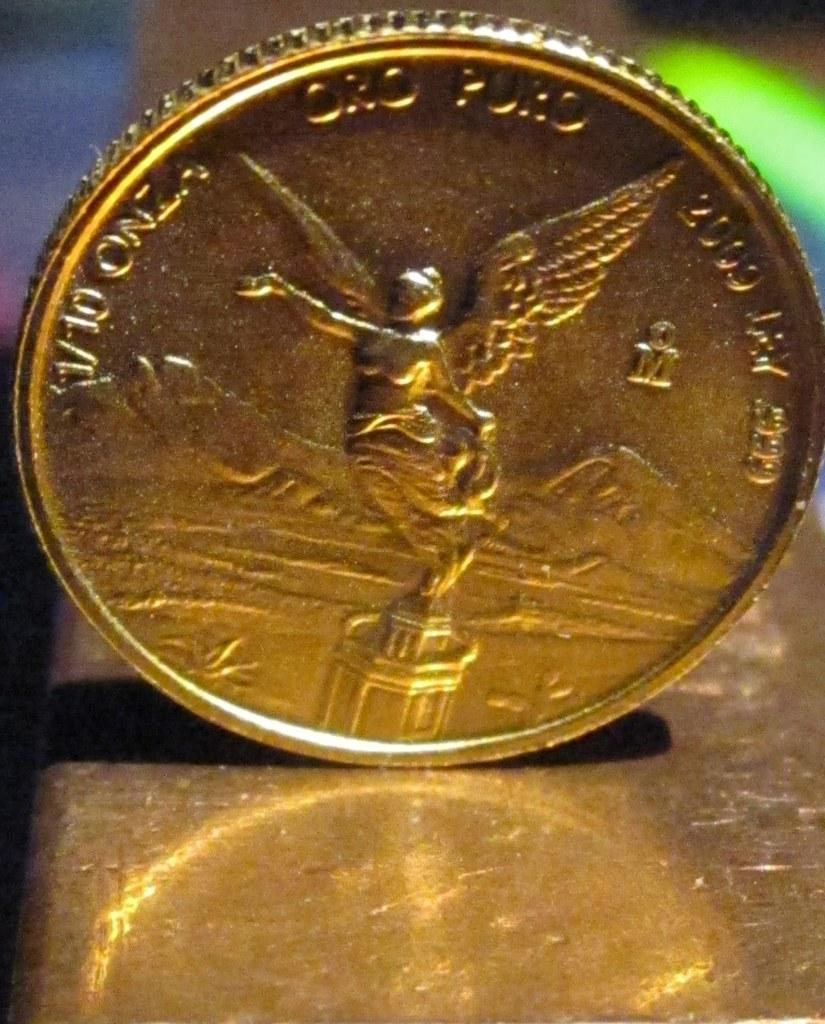Provide a one-sentence caption for the provided image. a gold coin with the number 2000 on it. 